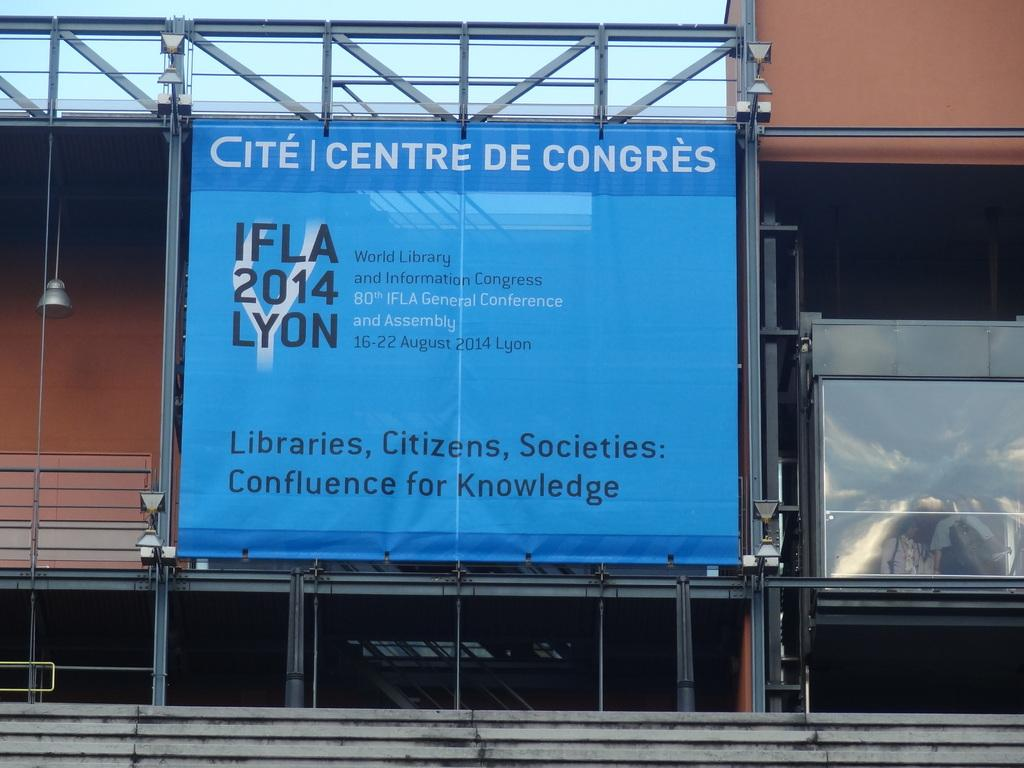<image>
Relay a brief, clear account of the picture shown. The year 2014 is on a large blue sign. 